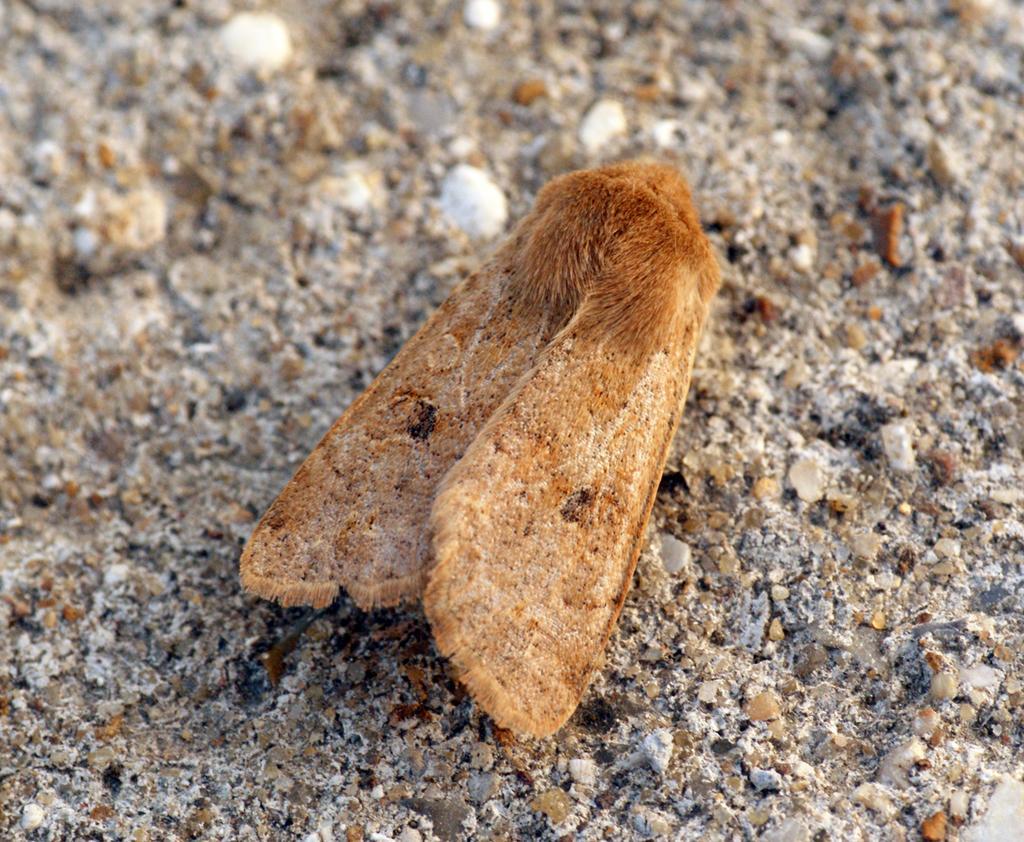Can you describe this image briefly? In this picture we can see an insect on the path. 